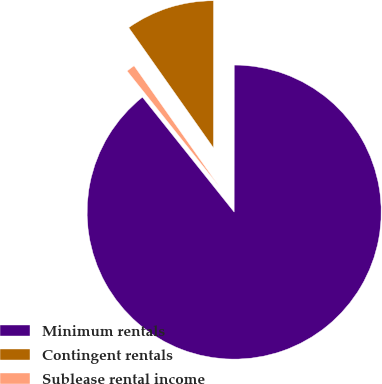<chart> <loc_0><loc_0><loc_500><loc_500><pie_chart><fcel>Minimum rentals<fcel>Contingent rentals<fcel>Sublease rental income<nl><fcel>89.27%<fcel>9.78%<fcel>0.95%<nl></chart> 